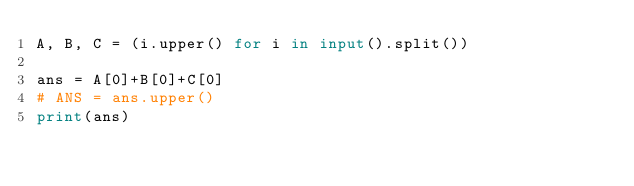<code> <loc_0><loc_0><loc_500><loc_500><_Python_>A, B, C = (i.upper() for i in input().split())

ans = A[0]+B[0]+C[0]
# ANS = ans.upper()
print(ans)</code> 